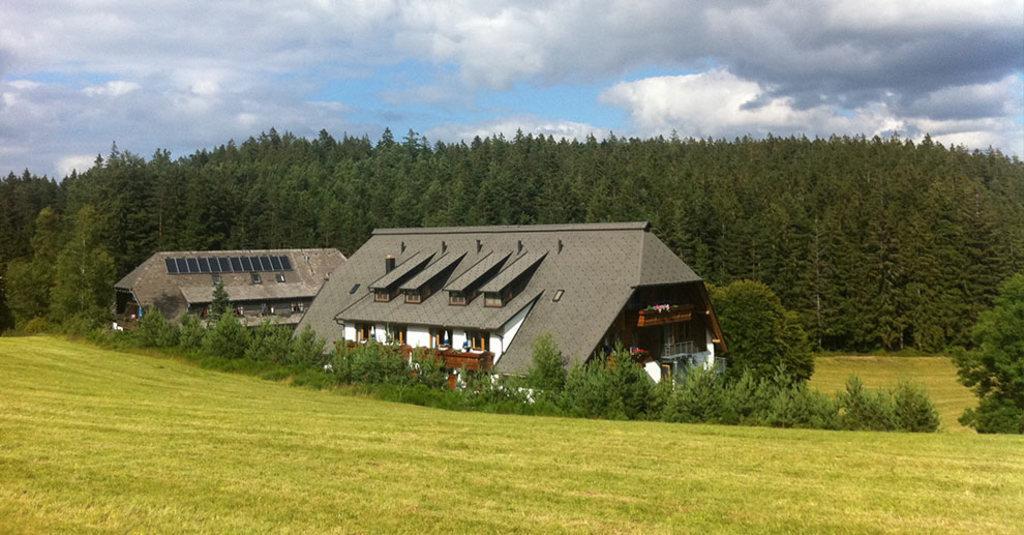Can you describe this image briefly? In this image I can see an open grass ground and on it I can see number of plants and two buildings. In the background I can see number of trees, clouds and the sky. 